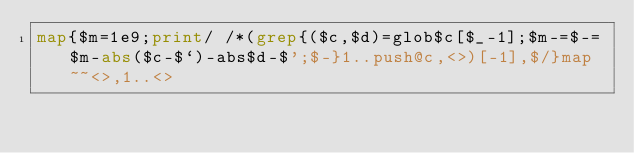Convert code to text. <code><loc_0><loc_0><loc_500><loc_500><_Perl_>map{$m=1e9;print/ /*(grep{($c,$d)=glob$c[$_-1];$m-=$-=$m-abs($c-$`)-abs$d-$';$-}1..push@c,<>)[-1],$/}map~~<>,1..<></code> 